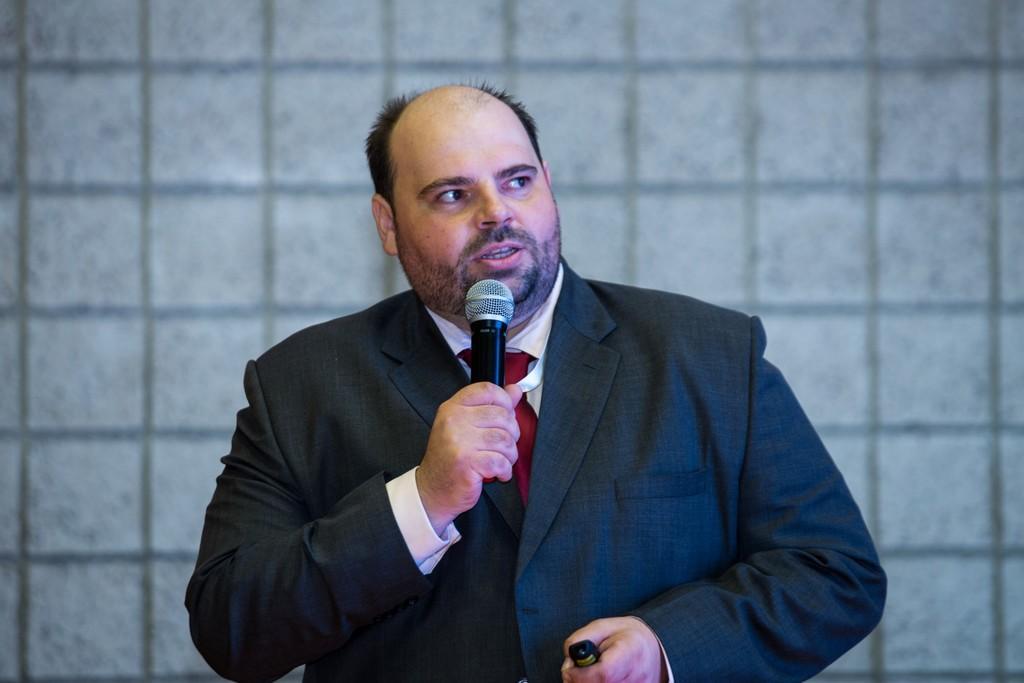Describe this image in one or two sentences. In this picture we can see a man wearing a blazer in his hand. He is holding a mike in his hand and talking. 